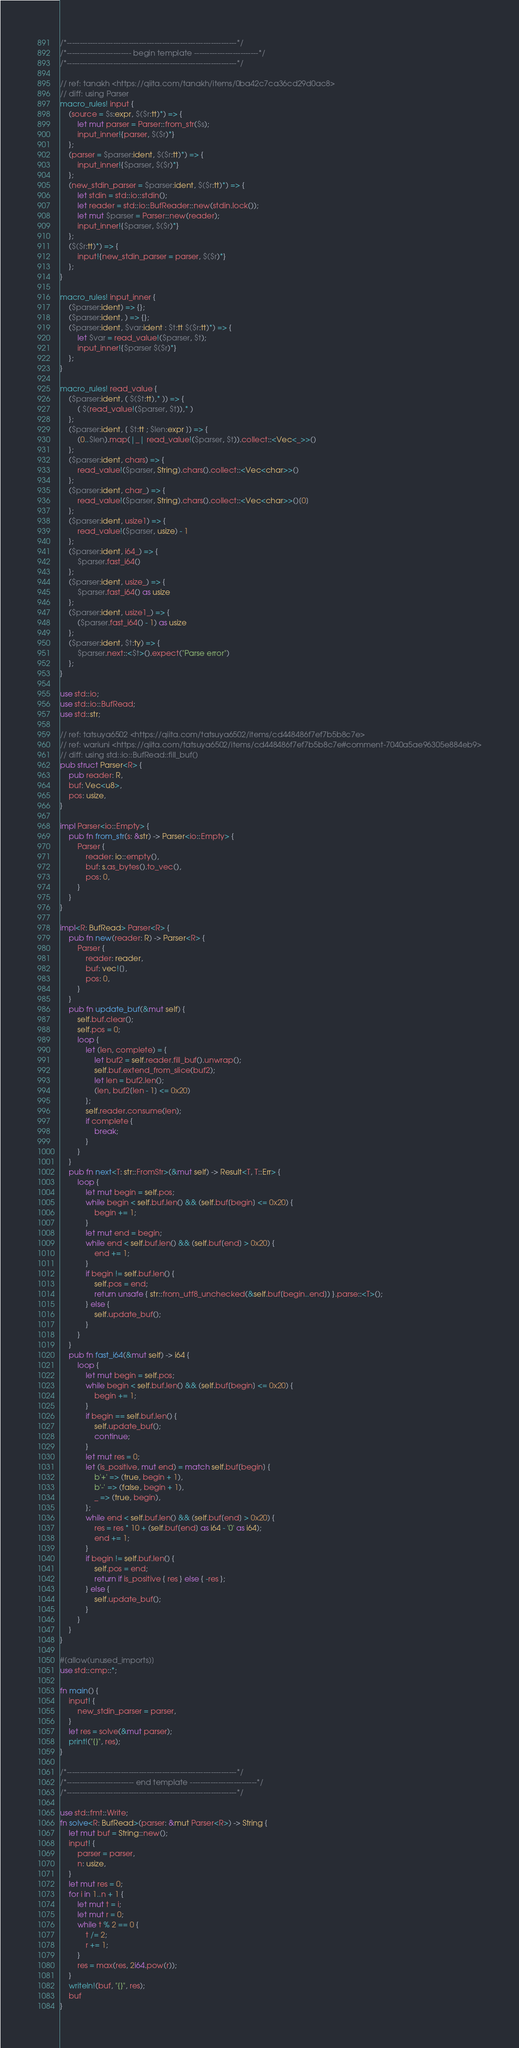Convert code to text. <code><loc_0><loc_0><loc_500><loc_500><_Rust_>/*------------------------------------------------------------------*/
/*------------------------- begin template -------------------------*/
/*------------------------------------------------------------------*/

// ref: tanakh <https://qiita.com/tanakh/items/0ba42c7ca36cd29d0ac8>
// diff: using Parser
macro_rules! input {
    (source = $s:expr, $($r:tt)*) => {
        let mut parser = Parser::from_str($s);
        input_inner!{parser, $($r)*}
    };
    (parser = $parser:ident, $($r:tt)*) => {
        input_inner!{$parser, $($r)*}
    };
    (new_stdin_parser = $parser:ident, $($r:tt)*) => {
        let stdin = std::io::stdin();
        let reader = std::io::BufReader::new(stdin.lock());
        let mut $parser = Parser::new(reader);
        input_inner!{$parser, $($r)*}
    };
    ($($r:tt)*) => {
        input!{new_stdin_parser = parser, $($r)*}
    };
}

macro_rules! input_inner {
    ($parser:ident) => {};
    ($parser:ident, ) => {};
    ($parser:ident, $var:ident : $t:tt $($r:tt)*) => {
        let $var = read_value!($parser, $t);
        input_inner!{$parser $($r)*}
    };
}

macro_rules! read_value {
    ($parser:ident, ( $($t:tt),* )) => {
        ( $(read_value!($parser, $t)),* )
    };
    ($parser:ident, [ $t:tt ; $len:expr ]) => {
        (0..$len).map(|_| read_value!($parser, $t)).collect::<Vec<_>>()
    };
    ($parser:ident, chars) => {
        read_value!($parser, String).chars().collect::<Vec<char>>()
    };
    ($parser:ident, char_) => {
        read_value!($parser, String).chars().collect::<Vec<char>>()[0]
    };
    ($parser:ident, usize1) => {
        read_value!($parser, usize) - 1
    };
    ($parser:ident, i64_) => {
        $parser.fast_i64()
    };
    ($parser:ident, usize_) => {
        $parser.fast_i64() as usize
    };
    ($parser:ident, usize1_) => {
        ($parser.fast_i64() - 1) as usize
    };
    ($parser:ident, $t:ty) => {
        $parser.next::<$t>().expect("Parse error")
    };
}

use std::io;
use std::io::BufRead;
use std::str;

// ref: tatsuya6502 <https://qiita.com/tatsuya6502/items/cd448486f7ef7b5b8c7e>
// ref: wariuni <https://qiita.com/tatsuya6502/items/cd448486f7ef7b5b8c7e#comment-7040a5ae96305e884eb9>
// diff: using std::io::BufRead::fill_buf()
pub struct Parser<R> {
    pub reader: R,
    buf: Vec<u8>,
    pos: usize,
}

impl Parser<io::Empty> {
    pub fn from_str(s: &str) -> Parser<io::Empty> {
        Parser {
            reader: io::empty(),
            buf: s.as_bytes().to_vec(),
            pos: 0,
        }
    }
}

impl<R: BufRead> Parser<R> {
    pub fn new(reader: R) -> Parser<R> {
        Parser {
            reader: reader,
            buf: vec![],
            pos: 0,
        }
    }
    pub fn update_buf(&mut self) {
        self.buf.clear();
        self.pos = 0;
        loop {
            let (len, complete) = {
                let buf2 = self.reader.fill_buf().unwrap();
                self.buf.extend_from_slice(buf2);
                let len = buf2.len();
                (len, buf2[len - 1] <= 0x20)
            };
            self.reader.consume(len);
            if complete {
                break;
            }
        }
    }
    pub fn next<T: str::FromStr>(&mut self) -> Result<T, T::Err> {
        loop {
            let mut begin = self.pos;
            while begin < self.buf.len() && (self.buf[begin] <= 0x20) {
                begin += 1;
            }
            let mut end = begin;
            while end < self.buf.len() && (self.buf[end] > 0x20) {
                end += 1;
            }
            if begin != self.buf.len() {
                self.pos = end;
                return unsafe { str::from_utf8_unchecked(&self.buf[begin..end]) }.parse::<T>();
            } else {
                self.update_buf();
            }
        }
    }
    pub fn fast_i64(&mut self) -> i64 {
        loop {
            let mut begin = self.pos;
            while begin < self.buf.len() && (self.buf[begin] <= 0x20) {
                begin += 1;
            }
            if begin == self.buf.len() {
                self.update_buf();
                continue;
            }
            let mut res = 0;
            let (is_positive, mut end) = match self.buf[begin] {
                b'+' => (true, begin + 1),
                b'-' => (false, begin + 1),
                _ => (true, begin),
            };
            while end < self.buf.len() && (self.buf[end] > 0x20) {
                res = res * 10 + (self.buf[end] as i64 - '0' as i64);
                end += 1;
            }
            if begin != self.buf.len() {
                self.pos = end;
                return if is_positive { res } else { -res };
            } else {
                self.update_buf();
            }
        }
    }
}

#[allow(unused_imports)]
use std::cmp::*;

fn main() {
    input! {
        new_stdin_parser = parser,
    }
    let res = solve(&mut parser);
    print!("{}", res);
}

/*------------------------------------------------------------------*/
/*-------------------------- end template --------------------------*/
/*------------------------------------------------------------------*/

use std::fmt::Write;
fn solve<R: BufRead>(parser: &mut Parser<R>) -> String {
    let mut buf = String::new();
    input! {
        parser = parser,
        n: usize,
    }
    let mut res = 0;
    for i in 1..n + 1 {
        let mut t = i;
        let mut r = 0;
        while t % 2 == 0 {
            t /= 2;
            r += 1;
        }
        res = max(res, 2i64.pow(r));
    }
    writeln!(buf, "{}", res);
    buf
}
</code> 